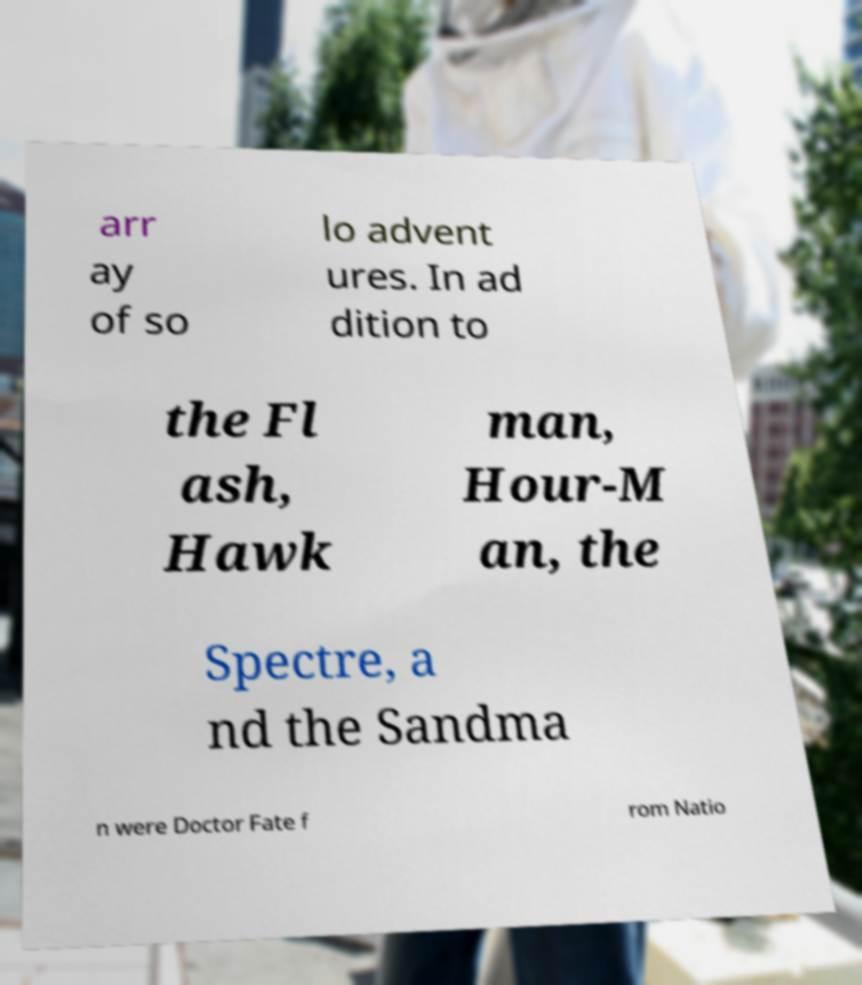Please read and relay the text visible in this image. What does it say? arr ay of so lo advent ures. In ad dition to the Fl ash, Hawk man, Hour-M an, the Spectre, a nd the Sandma n were Doctor Fate f rom Natio 